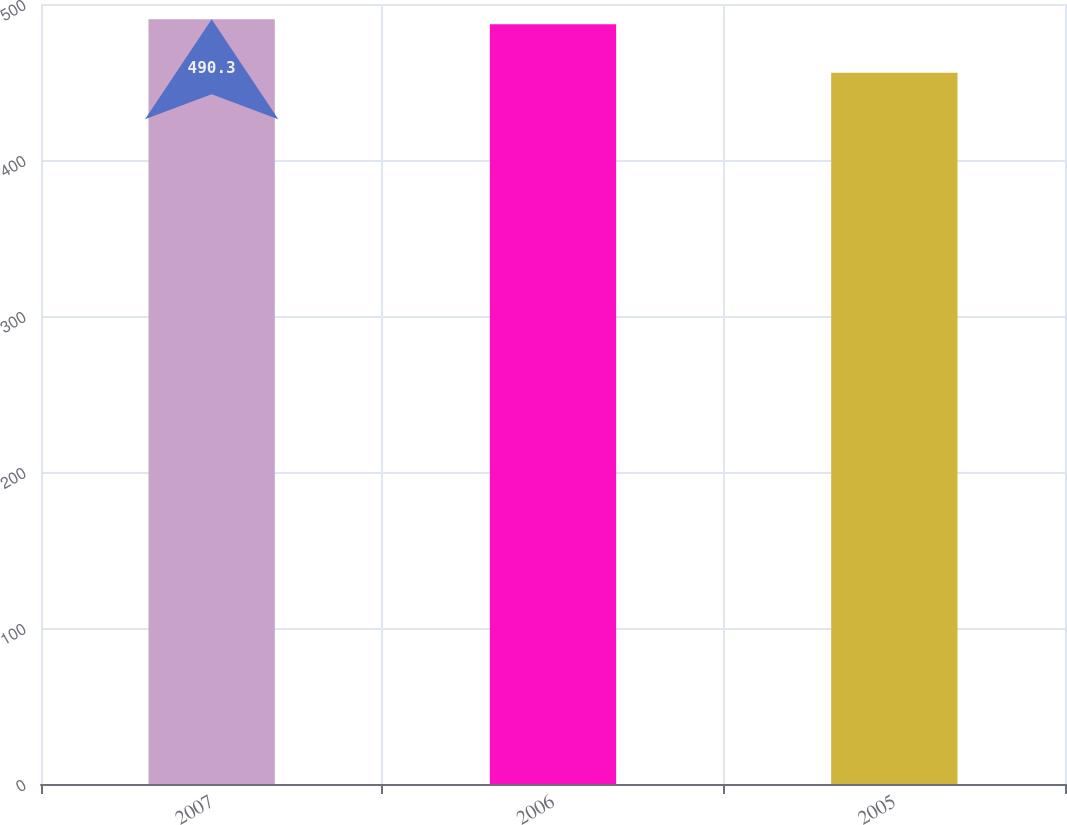<chart> <loc_0><loc_0><loc_500><loc_500><bar_chart><fcel>2007<fcel>2006<fcel>2005<nl><fcel>490.3<fcel>487<fcel>456<nl></chart> 